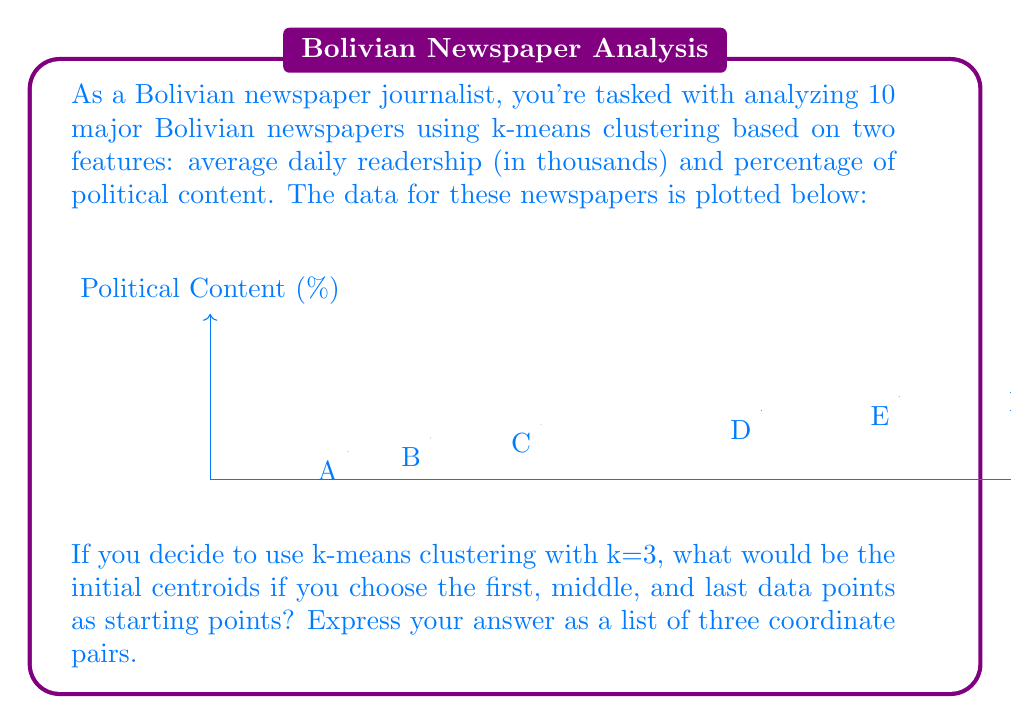Give your solution to this math problem. To solve this problem, we need to follow these steps:

1. Identify the first, middle, and last data points from the given plot.

2. The first data point is clearly labeled as A (50, 10).

3. To find the middle data point, we need to identify the 5th point in the ordered list. This is E (250, 30).

4. The last data point is J (500, 55).

5. These three points will serve as our initial centroids for k-means clustering with k=3.

6. Express the answer as a list of coordinate pairs in the order: (first, middle, last).

Therefore, the initial centroids for k-means clustering with k=3 would be:

$$(50, 10), (250, 30), (500, 55)$$

Each pair represents (Average Daily Readership, Political Content %) for the chosen newspapers.
Answer: $$(50, 10), (250, 30), (500, 55)$$ 